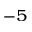<formula> <loc_0><loc_0><loc_500><loc_500>^ { - 5 }</formula> 